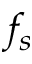<formula> <loc_0><loc_0><loc_500><loc_500>f _ { s }</formula> 